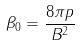<formula> <loc_0><loc_0><loc_500><loc_500>\beta _ { 0 } = \frac { 8 \pi p } { B ^ { 2 } }</formula> 